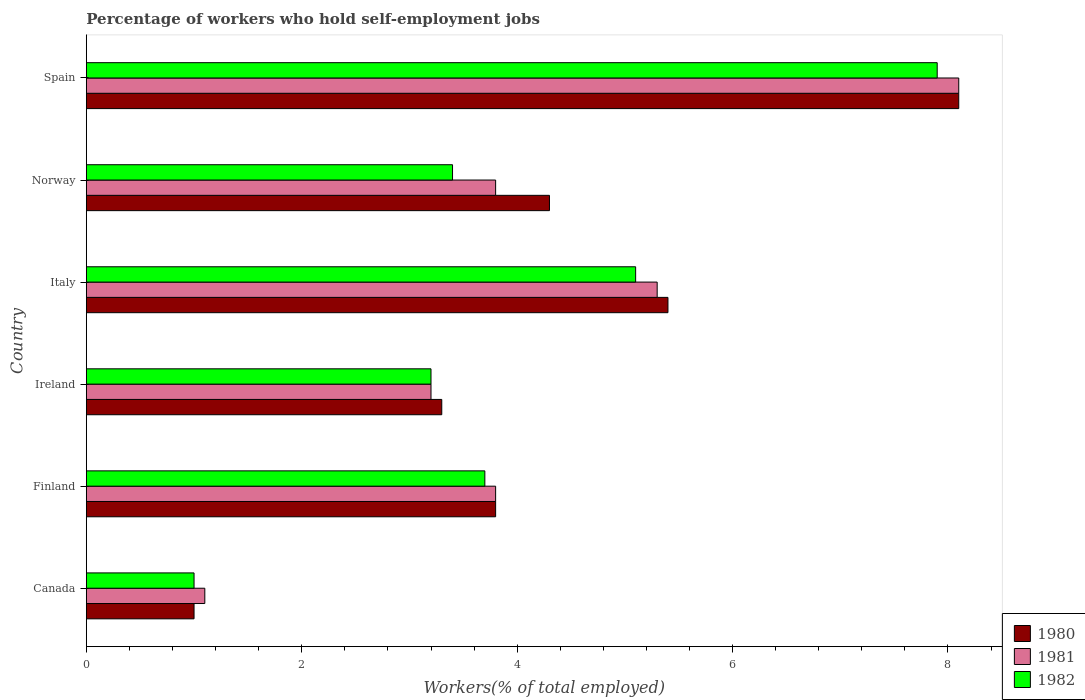How many groups of bars are there?
Your answer should be very brief. 6. Are the number of bars per tick equal to the number of legend labels?
Give a very brief answer. Yes. How many bars are there on the 4th tick from the top?
Make the answer very short. 3. What is the percentage of self-employed workers in 1982 in Norway?
Offer a terse response. 3.4. Across all countries, what is the maximum percentage of self-employed workers in 1981?
Offer a terse response. 8.1. Across all countries, what is the minimum percentage of self-employed workers in 1981?
Offer a very short reply. 1.1. What is the total percentage of self-employed workers in 1980 in the graph?
Your answer should be very brief. 25.9. What is the difference between the percentage of self-employed workers in 1980 in Italy and that in Norway?
Your response must be concise. 1.1. What is the difference between the percentage of self-employed workers in 1980 in Canada and the percentage of self-employed workers in 1982 in Ireland?
Your answer should be very brief. -2.2. What is the average percentage of self-employed workers in 1981 per country?
Provide a succinct answer. 4.22. What is the difference between the percentage of self-employed workers in 1982 and percentage of self-employed workers in 1981 in Canada?
Offer a very short reply. -0.1. What is the ratio of the percentage of self-employed workers in 1982 in Ireland to that in Spain?
Offer a very short reply. 0.41. Is the percentage of self-employed workers in 1982 in Canada less than that in Ireland?
Make the answer very short. Yes. What is the difference between the highest and the second highest percentage of self-employed workers in 1982?
Offer a terse response. 2.8. What is the difference between the highest and the lowest percentage of self-employed workers in 1980?
Give a very brief answer. 7.1. In how many countries, is the percentage of self-employed workers in 1982 greater than the average percentage of self-employed workers in 1982 taken over all countries?
Your answer should be compact. 2. Are all the bars in the graph horizontal?
Make the answer very short. Yes. How many countries are there in the graph?
Your answer should be compact. 6. Does the graph contain grids?
Your response must be concise. No. Where does the legend appear in the graph?
Provide a short and direct response. Bottom right. How many legend labels are there?
Provide a succinct answer. 3. How are the legend labels stacked?
Your answer should be very brief. Vertical. What is the title of the graph?
Make the answer very short. Percentage of workers who hold self-employment jobs. What is the label or title of the X-axis?
Your answer should be compact. Workers(% of total employed). What is the label or title of the Y-axis?
Offer a terse response. Country. What is the Workers(% of total employed) of 1980 in Canada?
Offer a terse response. 1. What is the Workers(% of total employed) of 1981 in Canada?
Offer a very short reply. 1.1. What is the Workers(% of total employed) of 1980 in Finland?
Provide a succinct answer. 3.8. What is the Workers(% of total employed) of 1981 in Finland?
Keep it short and to the point. 3.8. What is the Workers(% of total employed) in 1982 in Finland?
Provide a short and direct response. 3.7. What is the Workers(% of total employed) in 1980 in Ireland?
Ensure brevity in your answer.  3.3. What is the Workers(% of total employed) of 1981 in Ireland?
Ensure brevity in your answer.  3.2. What is the Workers(% of total employed) in 1982 in Ireland?
Keep it short and to the point. 3.2. What is the Workers(% of total employed) of 1980 in Italy?
Offer a terse response. 5.4. What is the Workers(% of total employed) of 1981 in Italy?
Your answer should be very brief. 5.3. What is the Workers(% of total employed) of 1982 in Italy?
Keep it short and to the point. 5.1. What is the Workers(% of total employed) in 1980 in Norway?
Your response must be concise. 4.3. What is the Workers(% of total employed) of 1981 in Norway?
Keep it short and to the point. 3.8. What is the Workers(% of total employed) of 1982 in Norway?
Give a very brief answer. 3.4. What is the Workers(% of total employed) of 1980 in Spain?
Keep it short and to the point. 8.1. What is the Workers(% of total employed) in 1981 in Spain?
Ensure brevity in your answer.  8.1. What is the Workers(% of total employed) of 1982 in Spain?
Your response must be concise. 7.9. Across all countries, what is the maximum Workers(% of total employed) in 1980?
Your response must be concise. 8.1. Across all countries, what is the maximum Workers(% of total employed) in 1981?
Give a very brief answer. 8.1. Across all countries, what is the maximum Workers(% of total employed) in 1982?
Give a very brief answer. 7.9. Across all countries, what is the minimum Workers(% of total employed) in 1980?
Your response must be concise. 1. Across all countries, what is the minimum Workers(% of total employed) in 1981?
Provide a succinct answer. 1.1. Across all countries, what is the minimum Workers(% of total employed) in 1982?
Your answer should be compact. 1. What is the total Workers(% of total employed) in 1980 in the graph?
Your answer should be very brief. 25.9. What is the total Workers(% of total employed) in 1981 in the graph?
Offer a very short reply. 25.3. What is the total Workers(% of total employed) of 1982 in the graph?
Your response must be concise. 24.3. What is the difference between the Workers(% of total employed) of 1982 in Canada and that in Finland?
Ensure brevity in your answer.  -2.7. What is the difference between the Workers(% of total employed) in 1980 in Canada and that in Italy?
Provide a short and direct response. -4.4. What is the difference between the Workers(% of total employed) of 1981 in Canada and that in Italy?
Your answer should be very brief. -4.2. What is the difference between the Workers(% of total employed) of 1980 in Canada and that in Norway?
Ensure brevity in your answer.  -3.3. What is the difference between the Workers(% of total employed) in 1981 in Canada and that in Norway?
Offer a terse response. -2.7. What is the difference between the Workers(% of total employed) of 1980 in Canada and that in Spain?
Keep it short and to the point. -7.1. What is the difference between the Workers(% of total employed) of 1981 in Canada and that in Spain?
Ensure brevity in your answer.  -7. What is the difference between the Workers(% of total employed) in 1980 in Finland and that in Ireland?
Keep it short and to the point. 0.5. What is the difference between the Workers(% of total employed) in 1982 in Finland and that in Ireland?
Your response must be concise. 0.5. What is the difference between the Workers(% of total employed) in 1980 in Finland and that in Norway?
Provide a short and direct response. -0.5. What is the difference between the Workers(% of total employed) of 1981 in Finland and that in Norway?
Offer a terse response. 0. What is the difference between the Workers(% of total employed) of 1980 in Finland and that in Spain?
Your answer should be very brief. -4.3. What is the difference between the Workers(% of total employed) of 1981 in Finland and that in Spain?
Provide a short and direct response. -4.3. What is the difference between the Workers(% of total employed) of 1982 in Finland and that in Spain?
Give a very brief answer. -4.2. What is the difference between the Workers(% of total employed) of 1981 in Ireland and that in Italy?
Make the answer very short. -2.1. What is the difference between the Workers(% of total employed) of 1982 in Ireland and that in Italy?
Provide a succinct answer. -1.9. What is the difference between the Workers(% of total employed) in 1980 in Ireland and that in Norway?
Your answer should be very brief. -1. What is the difference between the Workers(% of total employed) in 1981 in Ireland and that in Norway?
Keep it short and to the point. -0.6. What is the difference between the Workers(% of total employed) of 1980 in Ireland and that in Spain?
Give a very brief answer. -4.8. What is the difference between the Workers(% of total employed) of 1981 in Italy and that in Norway?
Offer a very short reply. 1.5. What is the difference between the Workers(% of total employed) in 1980 in Italy and that in Spain?
Your answer should be compact. -2.7. What is the difference between the Workers(% of total employed) of 1981 in Norway and that in Spain?
Make the answer very short. -4.3. What is the difference between the Workers(% of total employed) in 1982 in Norway and that in Spain?
Give a very brief answer. -4.5. What is the difference between the Workers(% of total employed) in 1980 in Canada and the Workers(% of total employed) in 1981 in Finland?
Ensure brevity in your answer.  -2.8. What is the difference between the Workers(% of total employed) in 1980 in Canada and the Workers(% of total employed) in 1981 in Ireland?
Offer a terse response. -2.2. What is the difference between the Workers(% of total employed) of 1981 in Canada and the Workers(% of total employed) of 1982 in Ireland?
Provide a short and direct response. -2.1. What is the difference between the Workers(% of total employed) in 1981 in Canada and the Workers(% of total employed) in 1982 in Italy?
Give a very brief answer. -4. What is the difference between the Workers(% of total employed) in 1980 in Canada and the Workers(% of total employed) in 1981 in Spain?
Offer a terse response. -7.1. What is the difference between the Workers(% of total employed) of 1980 in Finland and the Workers(% of total employed) of 1982 in Ireland?
Offer a terse response. 0.6. What is the difference between the Workers(% of total employed) of 1981 in Finland and the Workers(% of total employed) of 1982 in Ireland?
Give a very brief answer. 0.6. What is the difference between the Workers(% of total employed) of 1980 in Finland and the Workers(% of total employed) of 1981 in Italy?
Make the answer very short. -1.5. What is the difference between the Workers(% of total employed) in 1980 in Finland and the Workers(% of total employed) in 1982 in Italy?
Give a very brief answer. -1.3. What is the difference between the Workers(% of total employed) of 1981 in Finland and the Workers(% of total employed) of 1982 in Norway?
Your answer should be very brief. 0.4. What is the difference between the Workers(% of total employed) in 1981 in Finland and the Workers(% of total employed) in 1982 in Spain?
Offer a very short reply. -4.1. What is the difference between the Workers(% of total employed) of 1980 in Ireland and the Workers(% of total employed) of 1981 in Italy?
Keep it short and to the point. -2. What is the difference between the Workers(% of total employed) in 1980 in Ireland and the Workers(% of total employed) in 1982 in Italy?
Give a very brief answer. -1.8. What is the difference between the Workers(% of total employed) in 1981 in Ireland and the Workers(% of total employed) in 1982 in Italy?
Offer a terse response. -1.9. What is the difference between the Workers(% of total employed) in 1980 in Ireland and the Workers(% of total employed) in 1982 in Spain?
Your answer should be very brief. -4.6. What is the difference between the Workers(% of total employed) in 1980 in Italy and the Workers(% of total employed) in 1981 in Norway?
Your answer should be compact. 1.6. What is the difference between the Workers(% of total employed) of 1980 in Italy and the Workers(% of total employed) of 1982 in Norway?
Your answer should be compact. 2. What is the difference between the Workers(% of total employed) in 1981 in Italy and the Workers(% of total employed) in 1982 in Norway?
Provide a succinct answer. 1.9. What is the difference between the Workers(% of total employed) of 1980 in Italy and the Workers(% of total employed) of 1981 in Spain?
Offer a very short reply. -2.7. What is the average Workers(% of total employed) of 1980 per country?
Ensure brevity in your answer.  4.32. What is the average Workers(% of total employed) in 1981 per country?
Keep it short and to the point. 4.22. What is the average Workers(% of total employed) of 1982 per country?
Give a very brief answer. 4.05. What is the difference between the Workers(% of total employed) in 1980 and Workers(% of total employed) in 1982 in Canada?
Your answer should be compact. 0. What is the difference between the Workers(% of total employed) of 1981 and Workers(% of total employed) of 1982 in Canada?
Offer a terse response. 0.1. What is the difference between the Workers(% of total employed) in 1980 and Workers(% of total employed) in 1981 in Finland?
Give a very brief answer. 0. What is the difference between the Workers(% of total employed) of 1980 and Workers(% of total employed) of 1982 in Finland?
Provide a short and direct response. 0.1. What is the difference between the Workers(% of total employed) of 1980 and Workers(% of total employed) of 1981 in Ireland?
Offer a terse response. 0.1. What is the difference between the Workers(% of total employed) of 1980 and Workers(% of total employed) of 1982 in Ireland?
Your answer should be compact. 0.1. What is the difference between the Workers(% of total employed) in 1981 and Workers(% of total employed) in 1982 in Ireland?
Keep it short and to the point. 0. What is the difference between the Workers(% of total employed) of 1981 and Workers(% of total employed) of 1982 in Italy?
Provide a short and direct response. 0.2. What is the difference between the Workers(% of total employed) of 1980 and Workers(% of total employed) of 1982 in Norway?
Make the answer very short. 0.9. What is the difference between the Workers(% of total employed) of 1981 and Workers(% of total employed) of 1982 in Spain?
Provide a short and direct response. 0.2. What is the ratio of the Workers(% of total employed) in 1980 in Canada to that in Finland?
Offer a terse response. 0.26. What is the ratio of the Workers(% of total employed) in 1981 in Canada to that in Finland?
Give a very brief answer. 0.29. What is the ratio of the Workers(% of total employed) in 1982 in Canada to that in Finland?
Give a very brief answer. 0.27. What is the ratio of the Workers(% of total employed) of 1980 in Canada to that in Ireland?
Give a very brief answer. 0.3. What is the ratio of the Workers(% of total employed) in 1981 in Canada to that in Ireland?
Offer a very short reply. 0.34. What is the ratio of the Workers(% of total employed) in 1982 in Canada to that in Ireland?
Your answer should be compact. 0.31. What is the ratio of the Workers(% of total employed) of 1980 in Canada to that in Italy?
Make the answer very short. 0.19. What is the ratio of the Workers(% of total employed) in 1981 in Canada to that in Italy?
Give a very brief answer. 0.21. What is the ratio of the Workers(% of total employed) of 1982 in Canada to that in Italy?
Ensure brevity in your answer.  0.2. What is the ratio of the Workers(% of total employed) in 1980 in Canada to that in Norway?
Keep it short and to the point. 0.23. What is the ratio of the Workers(% of total employed) in 1981 in Canada to that in Norway?
Your answer should be very brief. 0.29. What is the ratio of the Workers(% of total employed) in 1982 in Canada to that in Norway?
Your answer should be very brief. 0.29. What is the ratio of the Workers(% of total employed) in 1980 in Canada to that in Spain?
Offer a terse response. 0.12. What is the ratio of the Workers(% of total employed) of 1981 in Canada to that in Spain?
Make the answer very short. 0.14. What is the ratio of the Workers(% of total employed) in 1982 in Canada to that in Spain?
Offer a very short reply. 0.13. What is the ratio of the Workers(% of total employed) of 1980 in Finland to that in Ireland?
Your answer should be compact. 1.15. What is the ratio of the Workers(% of total employed) in 1981 in Finland to that in Ireland?
Your answer should be compact. 1.19. What is the ratio of the Workers(% of total employed) in 1982 in Finland to that in Ireland?
Give a very brief answer. 1.16. What is the ratio of the Workers(% of total employed) of 1980 in Finland to that in Italy?
Provide a succinct answer. 0.7. What is the ratio of the Workers(% of total employed) in 1981 in Finland to that in Italy?
Keep it short and to the point. 0.72. What is the ratio of the Workers(% of total employed) of 1982 in Finland to that in Italy?
Offer a very short reply. 0.73. What is the ratio of the Workers(% of total employed) of 1980 in Finland to that in Norway?
Provide a short and direct response. 0.88. What is the ratio of the Workers(% of total employed) of 1981 in Finland to that in Norway?
Your answer should be compact. 1. What is the ratio of the Workers(% of total employed) in 1982 in Finland to that in Norway?
Offer a very short reply. 1.09. What is the ratio of the Workers(% of total employed) of 1980 in Finland to that in Spain?
Offer a very short reply. 0.47. What is the ratio of the Workers(% of total employed) of 1981 in Finland to that in Spain?
Provide a short and direct response. 0.47. What is the ratio of the Workers(% of total employed) in 1982 in Finland to that in Spain?
Provide a succinct answer. 0.47. What is the ratio of the Workers(% of total employed) in 1980 in Ireland to that in Italy?
Provide a short and direct response. 0.61. What is the ratio of the Workers(% of total employed) of 1981 in Ireland to that in Italy?
Give a very brief answer. 0.6. What is the ratio of the Workers(% of total employed) of 1982 in Ireland to that in Italy?
Provide a succinct answer. 0.63. What is the ratio of the Workers(% of total employed) of 1980 in Ireland to that in Norway?
Your response must be concise. 0.77. What is the ratio of the Workers(% of total employed) of 1981 in Ireland to that in Norway?
Give a very brief answer. 0.84. What is the ratio of the Workers(% of total employed) of 1980 in Ireland to that in Spain?
Offer a terse response. 0.41. What is the ratio of the Workers(% of total employed) in 1981 in Ireland to that in Spain?
Ensure brevity in your answer.  0.4. What is the ratio of the Workers(% of total employed) of 1982 in Ireland to that in Spain?
Make the answer very short. 0.41. What is the ratio of the Workers(% of total employed) in 1980 in Italy to that in Norway?
Keep it short and to the point. 1.26. What is the ratio of the Workers(% of total employed) of 1981 in Italy to that in Norway?
Your answer should be very brief. 1.39. What is the ratio of the Workers(% of total employed) in 1980 in Italy to that in Spain?
Your response must be concise. 0.67. What is the ratio of the Workers(% of total employed) of 1981 in Italy to that in Spain?
Provide a succinct answer. 0.65. What is the ratio of the Workers(% of total employed) of 1982 in Italy to that in Spain?
Your answer should be compact. 0.65. What is the ratio of the Workers(% of total employed) in 1980 in Norway to that in Spain?
Your answer should be compact. 0.53. What is the ratio of the Workers(% of total employed) in 1981 in Norway to that in Spain?
Make the answer very short. 0.47. What is the ratio of the Workers(% of total employed) of 1982 in Norway to that in Spain?
Make the answer very short. 0.43. What is the difference between the highest and the second highest Workers(% of total employed) of 1982?
Your answer should be compact. 2.8. What is the difference between the highest and the lowest Workers(% of total employed) in 1982?
Keep it short and to the point. 6.9. 